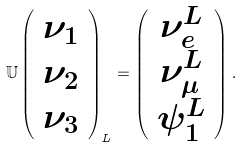Convert formula to latex. <formula><loc_0><loc_0><loc_500><loc_500>\mathbb { U } \left ( \begin{array} { c } \nu _ { 1 } \\ \nu _ { 2 } \\ \nu _ { 3 } \end{array} \right ) _ { L } = \left ( \begin{array} { c } \nu _ { e } ^ { L } \\ \nu _ { \mu } ^ { L } \\ \psi _ { 1 } ^ { L } \end{array} \right ) .</formula> 